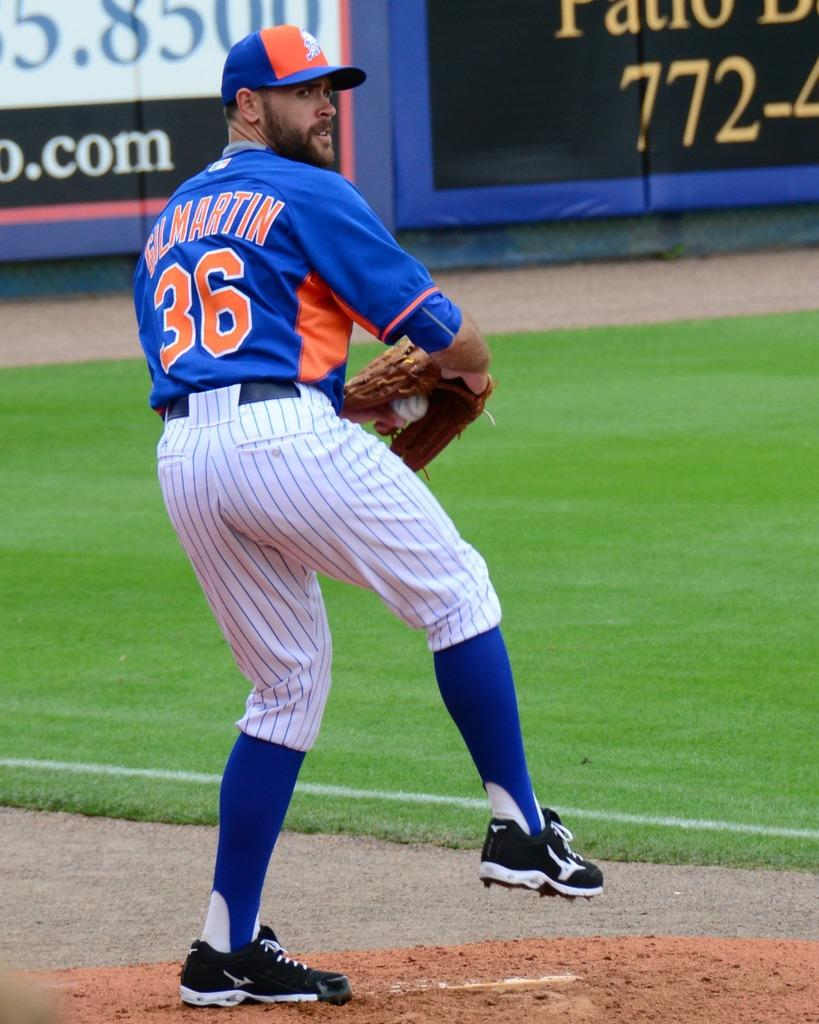<image>
Relay a brief, clear account of the picture shown. A man in a baseball uniform with the name Gil Martin and number 36 on the back of his jersey. 